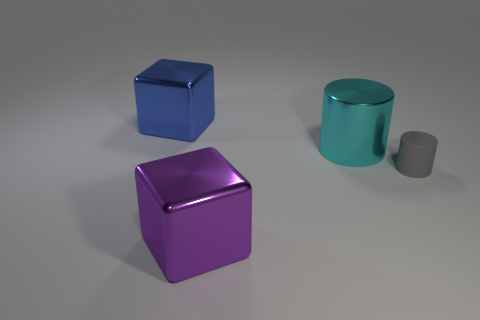Add 1 purple spheres. How many objects exist? 5 Subtract all blue blocks. How many blocks are left? 1 Add 2 tiny cubes. How many tiny cubes exist? 2 Subtract 0 blue cylinders. How many objects are left? 4 Subtract 1 blocks. How many blocks are left? 1 Subtract all gray cubes. Subtract all blue balls. How many cubes are left? 2 Subtract all green balls. How many purple cubes are left? 1 Subtract all small green objects. Subtract all large cyan cylinders. How many objects are left? 3 Add 2 cyan shiny objects. How many cyan shiny objects are left? 3 